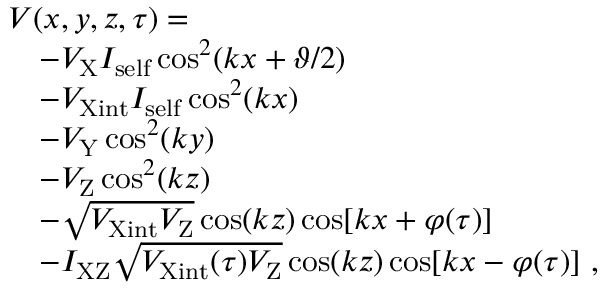Convert formula to latex. <formula><loc_0><loc_0><loc_500><loc_500>\begin{array} { r l } & { V ( x , y , z , \tau ) = } \\ & { \quad - V _ { X } I _ { s e l f } \cos ^ { 2 } ( k x + \vartheta / 2 ) } \\ & { \quad - V _ { X i n t } I _ { s e l f } \cos ^ { 2 } ( k x ) } \\ & { \quad - V _ { Y } \cos ^ { 2 } ( k y ) } \\ & { \quad - V _ { Z } \cos ^ { 2 } ( k z ) } \\ & { \quad - \sqrt { V _ { X i n t } V _ { Z } } \cos ( k z ) \cos [ k x + \varphi ( \tau ) ] } \\ & { \quad - I _ { X Z } \sqrt { V _ { X i n t } ( \tau ) V _ { Z } } \cos ( k z ) \cos [ k x - \varphi ( \tau ) ] , } \end{array}</formula> 